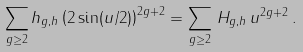<formula> <loc_0><loc_0><loc_500><loc_500>\sum _ { g \geq 2 } h _ { g , h } \left ( 2 \sin ( u / 2 ) \right ) ^ { 2 g + 2 } = \sum _ { g \geq 2 } \, H _ { g , h } \, u ^ { 2 g + 2 } \, .</formula> 